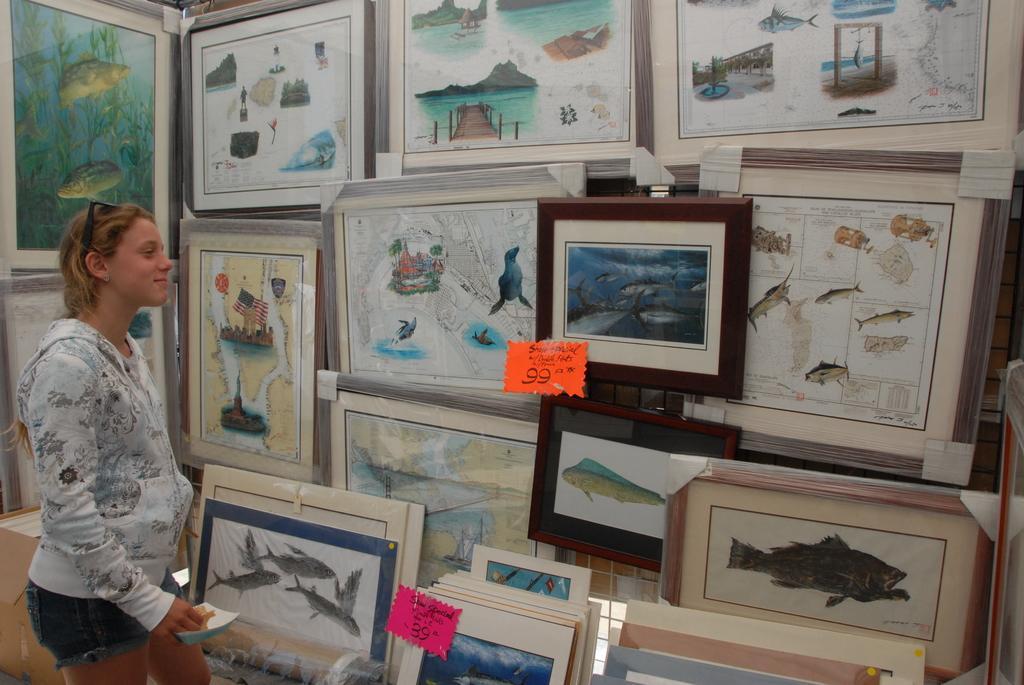Please provide a concise description of this image. In this picture we can see a woman, here we can see photo frames, stickers and some objects. 